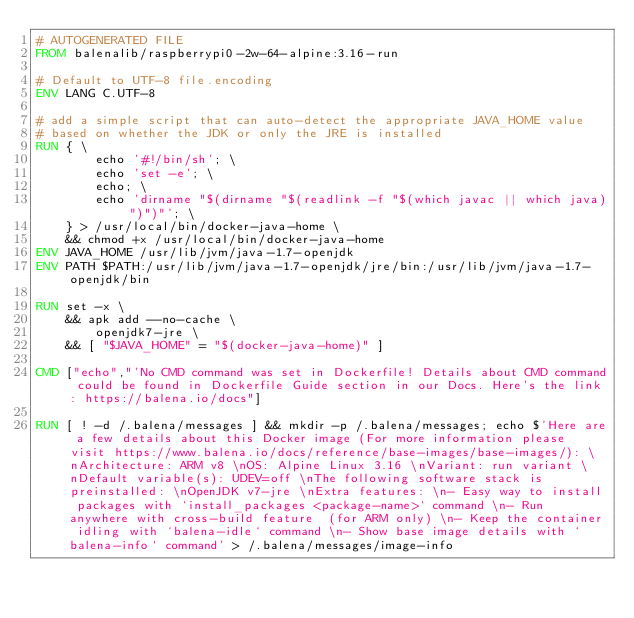Convert code to text. <code><loc_0><loc_0><loc_500><loc_500><_Dockerfile_># AUTOGENERATED FILE
FROM balenalib/raspberrypi0-2w-64-alpine:3.16-run

# Default to UTF-8 file.encoding
ENV LANG C.UTF-8

# add a simple script that can auto-detect the appropriate JAVA_HOME value
# based on whether the JDK or only the JRE is installed
RUN { \
		echo '#!/bin/sh'; \
		echo 'set -e'; \
		echo; \
		echo 'dirname "$(dirname "$(readlink -f "$(which javac || which java)")")"'; \
	} > /usr/local/bin/docker-java-home \
	&& chmod +x /usr/local/bin/docker-java-home
ENV JAVA_HOME /usr/lib/jvm/java-1.7-openjdk
ENV PATH $PATH:/usr/lib/jvm/java-1.7-openjdk/jre/bin:/usr/lib/jvm/java-1.7-openjdk/bin

RUN set -x \
	&& apk add --no-cache \
		openjdk7-jre \
	&& [ "$JAVA_HOME" = "$(docker-java-home)" ]

CMD ["echo","'No CMD command was set in Dockerfile! Details about CMD command could be found in Dockerfile Guide section in our Docs. Here's the link: https://balena.io/docs"]

RUN [ ! -d /.balena/messages ] && mkdir -p /.balena/messages; echo $'Here are a few details about this Docker image (For more information please visit https://www.balena.io/docs/reference/base-images/base-images/): \nArchitecture: ARM v8 \nOS: Alpine Linux 3.16 \nVariant: run variant \nDefault variable(s): UDEV=off \nThe following software stack is preinstalled: \nOpenJDK v7-jre \nExtra features: \n- Easy way to install packages with `install_packages <package-name>` command \n- Run anywhere with cross-build feature  (for ARM only) \n- Keep the container idling with `balena-idle` command \n- Show base image details with `balena-info` command' > /.balena/messages/image-info</code> 